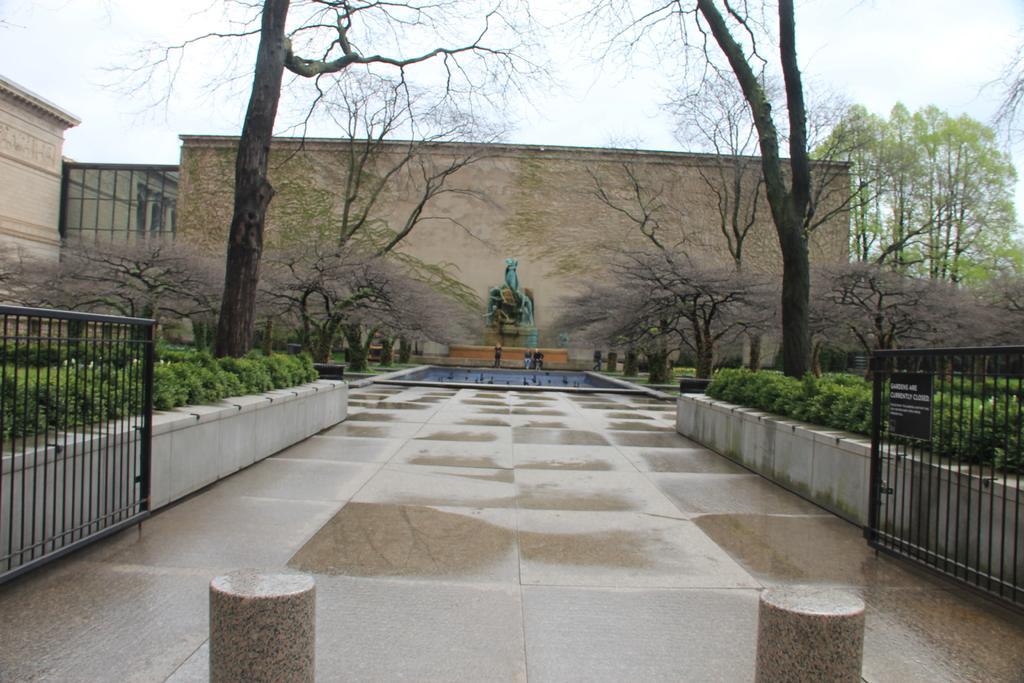Can you describe this image briefly? In this image I can see a wall with a statue in the center. Some people are standing and an artificial fountain or a water pool. I can see a walkway from the bottom towards the center of the image. I can see trees and plants on both sides of the image. I can see a gate opens with two wings, one is on the right one is on the left side of the image. I can see two pillars like structures at the bottom of the image. On the left hand side of the image I can see a building. At the top of the image I can see the sky 